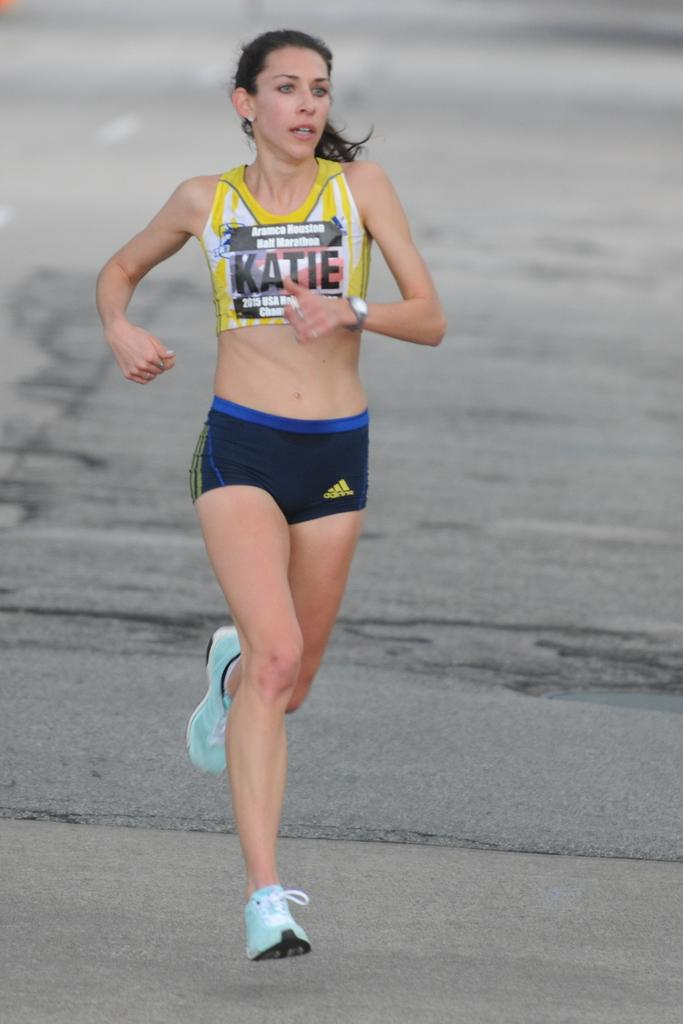<image>
Summarize the visual content of the image. A slim young women running in Adidas shorts and a crop top which has "Katie" on the front. 